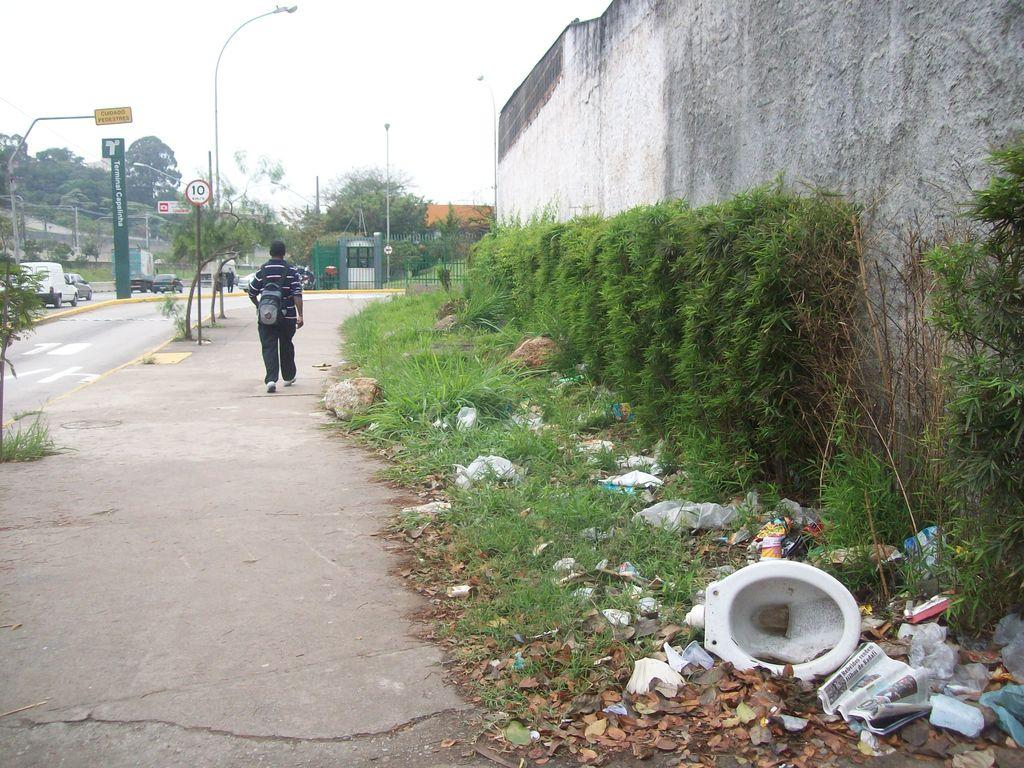What is the man in the image doing? The man is walking in the image. On what surface is the man walking? The man is walking on a path. What can be seen on the right side of the image? There are plants on the right side of the image. What is present on the ground in the image? There is garbage on the ground in the image. What is visible in the background of the image? There are trees and the sky in the background of the image. What type of underwear is the man wearing in the image? There is no information about the man's underwear in the image, so it cannot be determined. Can you tell me how much the receipt costs in the image? There is no receipt present in the image, so it cannot be determined. 